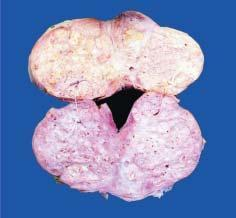how does sectioned surface of enlarged prostate show soft to firm, grey-white, nodularity?
Answer the question using a single word or phrase. With microcystic areas 